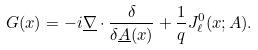<formula> <loc_0><loc_0><loc_500><loc_500>G ( x ) = - i \underline { \nabla } \cdot \frac { \delta } { \delta \underline { A } ( x ) } + \frac { 1 } { q } J _ { \ell } ^ { 0 } ( x ; A ) .</formula> 